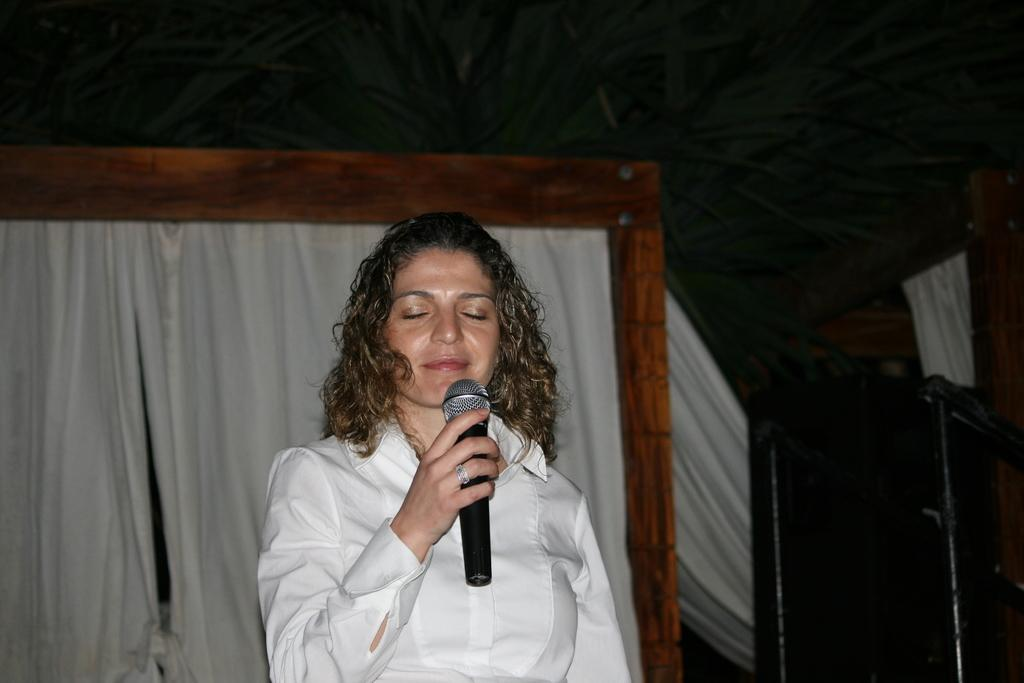What is the person in the image doing? The person is holding a microphone. What can be seen in the background of the image? There is a wooden object and curtains in the background of the image. What is located in the bottom right corner of the image? There is an object in the bottom right corner of the image. What year does the person regret in the image? There is no indication of regret or a specific year in the image. 